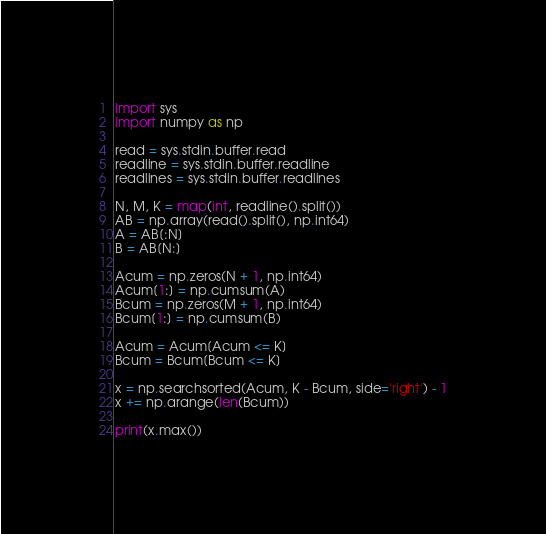Convert code to text. <code><loc_0><loc_0><loc_500><loc_500><_Python_>import sys
import numpy as np

read = sys.stdin.buffer.read
readline = sys.stdin.buffer.readline
readlines = sys.stdin.buffer.readlines

N, M, K = map(int, readline().split())
AB = np.array(read().split(), np.int64)
A = AB[:N]
B = AB[N:]

Acum = np.zeros(N + 1, np.int64)
Acum[1:] = np.cumsum(A)
Bcum = np.zeros(M + 1, np.int64)
Bcum[1:] = np.cumsum(B)

Acum = Acum[Acum <= K]
Bcum = Bcum[Bcum <= K]

x = np.searchsorted(Acum, K - Bcum, side='right') - 1
x += np.arange(len(Bcum))

print(x.max())</code> 